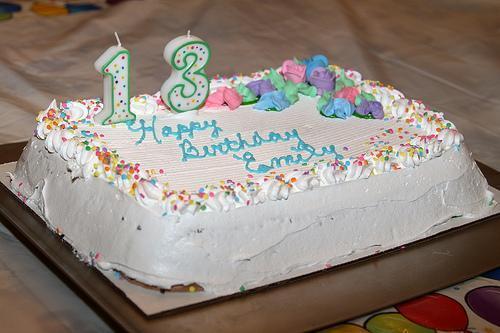How many of each color flower is on the cake?
Give a very brief answer. 3. 